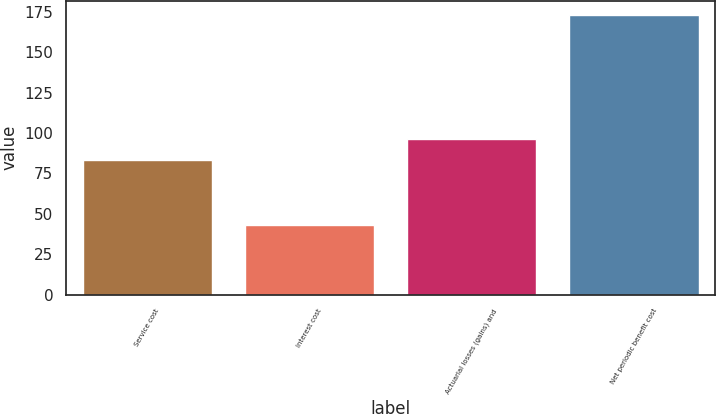Convert chart to OTSL. <chart><loc_0><loc_0><loc_500><loc_500><bar_chart><fcel>Service cost<fcel>Interest cost<fcel>Actuarial losses (gains) and<fcel>Net periodic benefit cost<nl><fcel>83<fcel>43<fcel>96<fcel>173<nl></chart> 